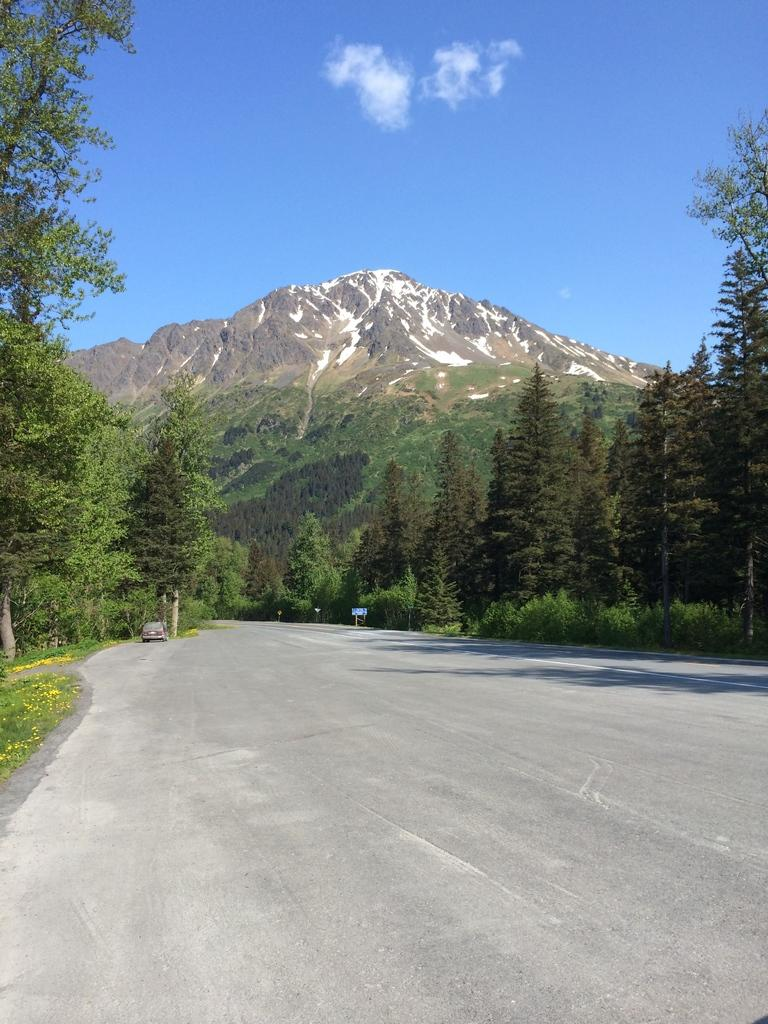What type of vegetation can be seen in the image? There are trees in the image. What geographical feature is present in the image? There is a mountain in the image. What part of the natural environment is visible in the image? The sky is visible in the image. What type of man-made structure can be seen in the image? There is a vehicle on the road in the image. What type of ground cover is present in the image? There is grass in the image. What type of silk is being used to cover the mountain in the image? There is no silk present in the image, and the mountain is not covered. What type of shame is being expressed by the trees in the image? There is no shame expressed by the trees in the image; they are simply trees. 